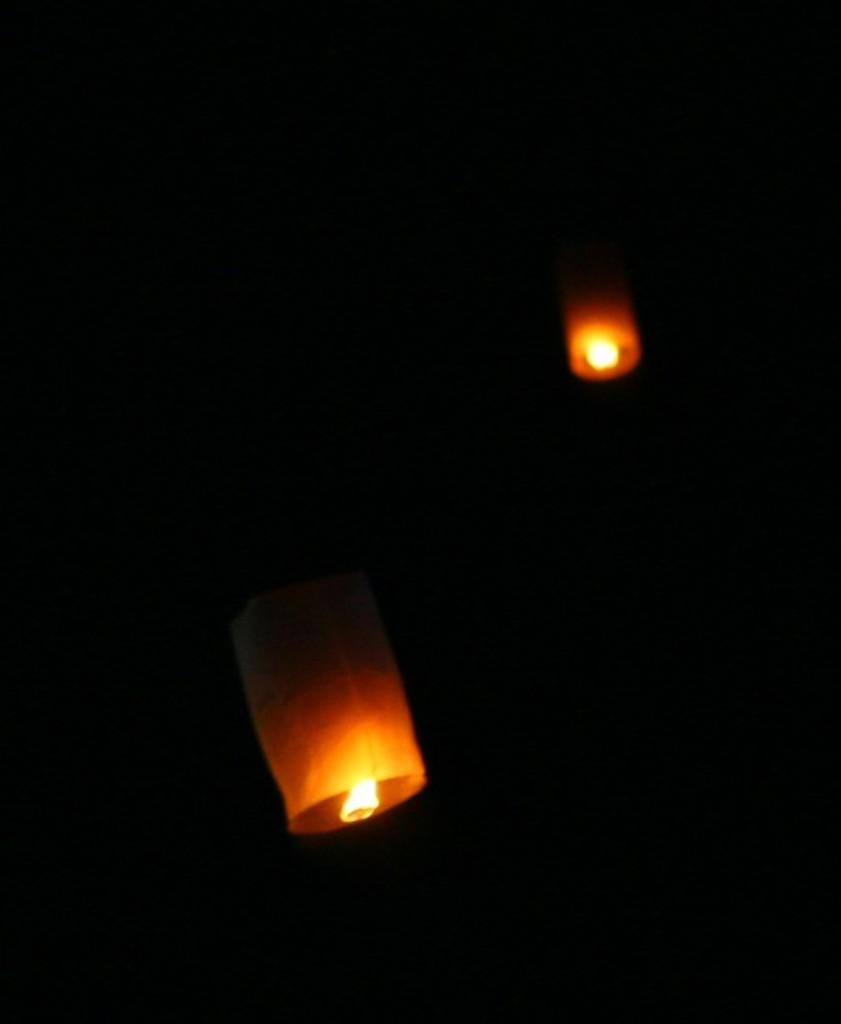How many lanterns are visible in the image? There are two lanterns in the image. What can be observed about the background of the image? The background of the image is dark. What type of credit card is being used to purchase the lanterns in the image? There is no credit card or purchase activity depicted in the image; it only shows two lanterns and a dark background. 